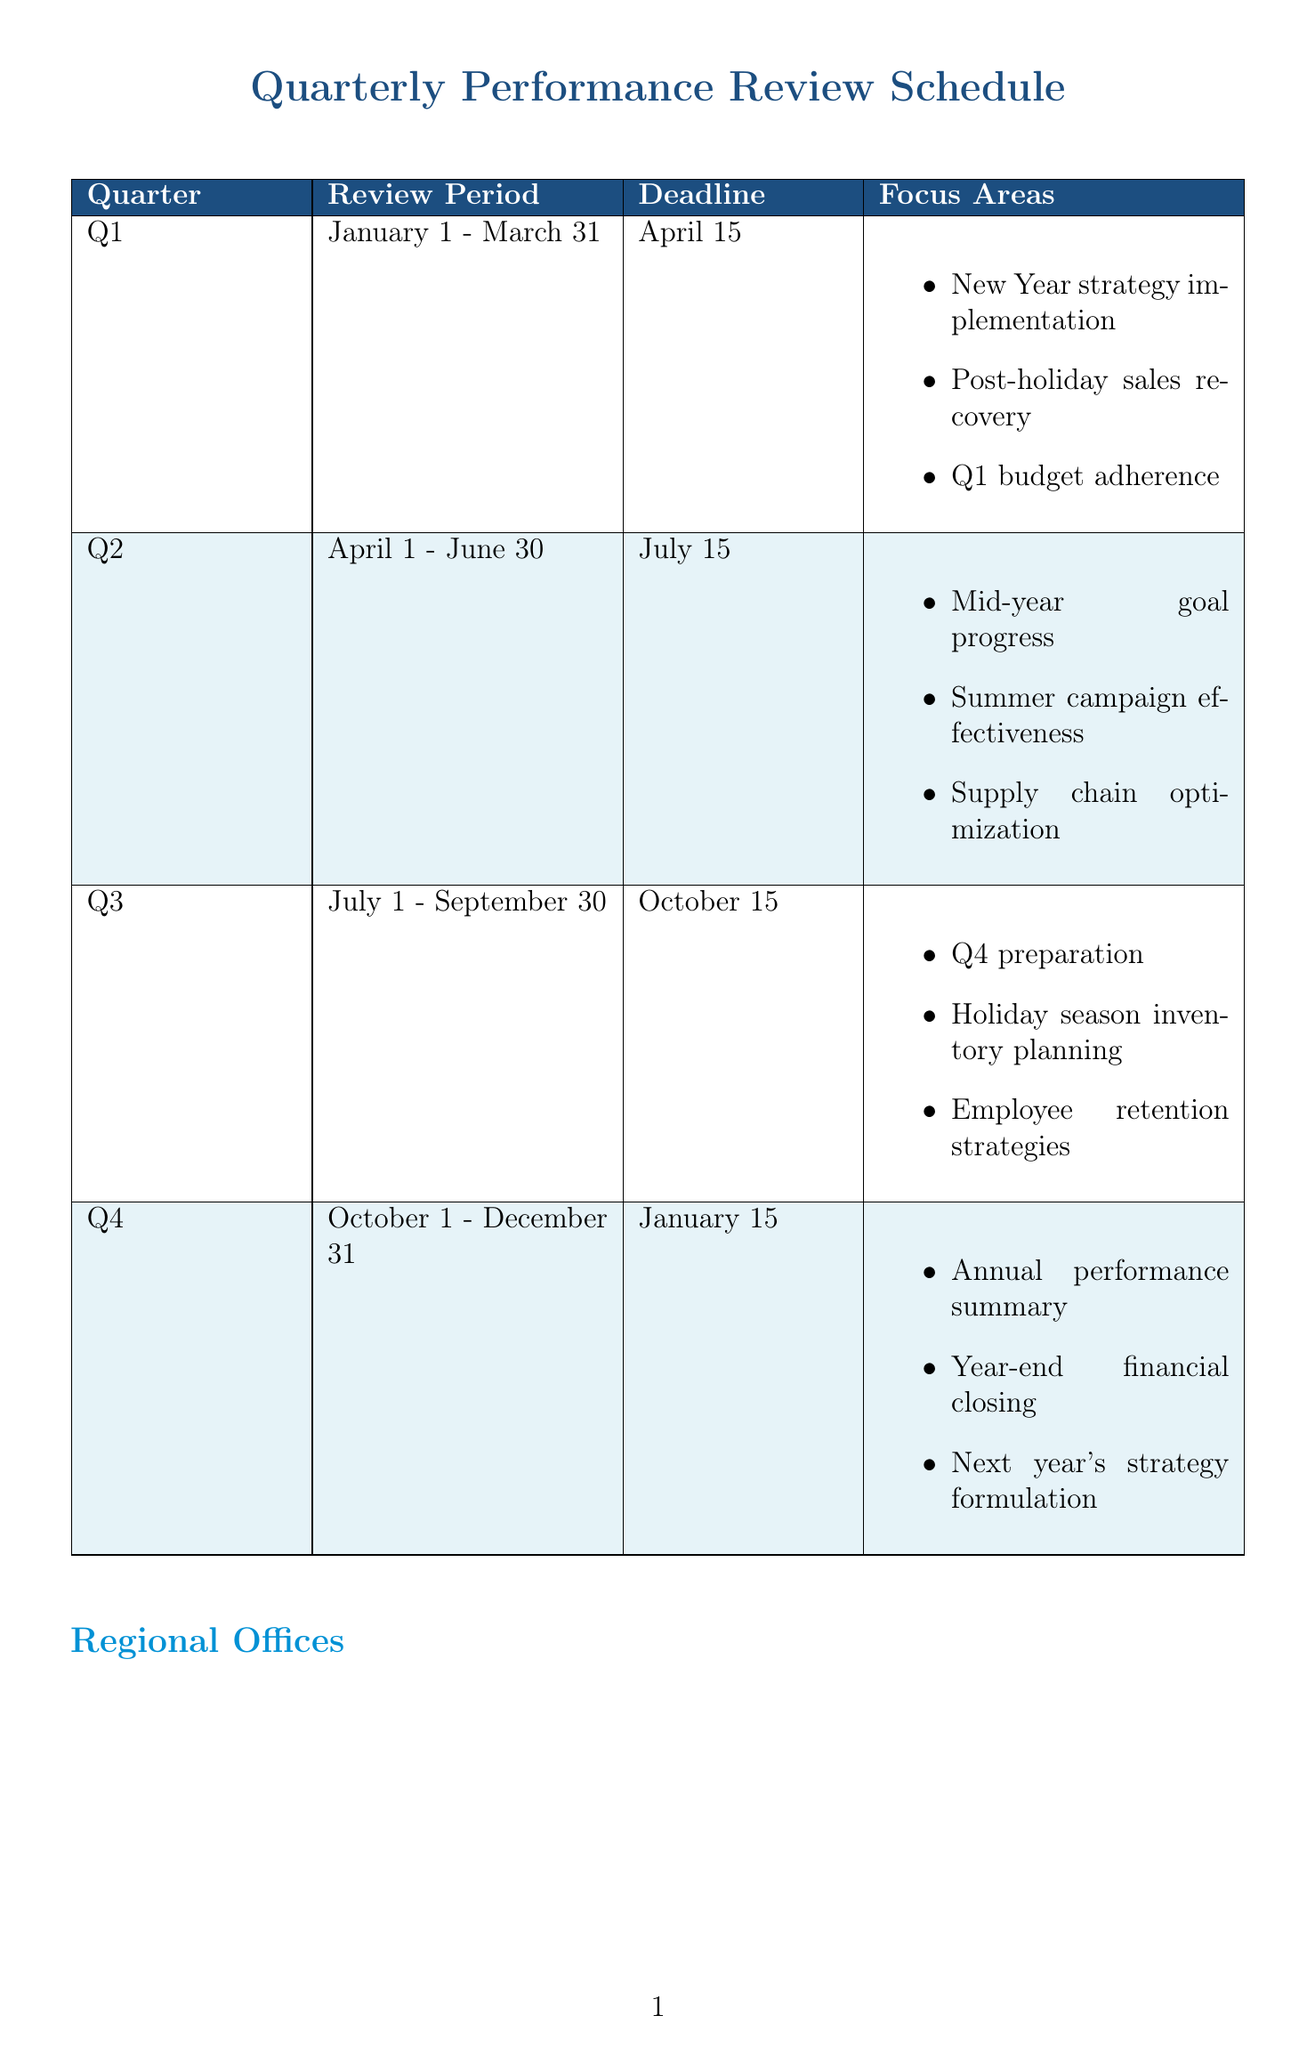What is the review period for Q2? The review period for Q2 is from April 1 to June 30.
Answer: April 1 - June 30 What is the deadline for Q3 reviews? The deadline for Q3 reviews is stated in the schedule for the review period from July 1 to September 30.
Answer: October 15 What are the key markets for the EMEA Headquarters? The key markets for the EMEA Headquarters are listed in the regional offices section of the document.
Answer: United Kingdom, Germany, France, UAE What is the weight of the Customer Satisfaction Score KPI? The weight of the Customer Satisfaction Score KPI can be found in the KPI targets section under the Operational category.
Answer: 20% Which cultural consideration is important in Japan? The cultural considerations for the APAC region mention this specific requirement related to Japan.
Answer: Importance of face-to-face meetings How many business days are allocated for data collection and verification in the review process? This information is available in the review process section where each step and its duration are listed.
Answer: 5 business days How many focus areas are listed for Q4? The focus areas for Q4 can be counted in the respective section of the schedule.
Answer: 3 What is the KPI target for Market Share? The KPI target for Market Share is listed under the Strategic category in the KPI targets section.
Answer: 2% increase in key markets 